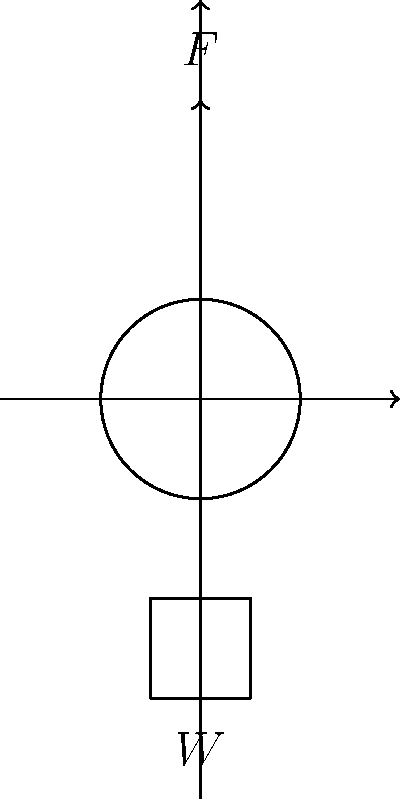E aí, cara! Tamo trabalhando num sistema de polia simples pra um equipamento de academia. Se a força $F$ aplicada pra levantar um peso $W$ é 200 N, qual é o peso da carga sendo levantada? Considera que não tem atrito e que a polia é ideal. Beleza, vamo nessa! Pra resolver isso, a gente precisa entender como funciona uma polia simples:

1) Numa polia simples ideal, a força aplicada $F$ é igual à tensão na corda.

2) Como a corda passa pela polia e sustenta o peso, a tensão na corda é igual ao peso $W$ que tá sendo levantado.

3) Então, numa polia simples ideal, a força aplicada $F$ é igual ao peso $W$ que tá sendo levantado.

4) Matematicamente, a gente pode escrever isso como:

   $$F = W$$

5) A gente sabe que a força aplicada $F$ é 200 N, então:

   $$200 \text{ N} = W$$

6) Portanto, o peso $W$ sendo levantado também é 200 N.

É isso aí, parceiro! Simples assim numa polia ideal.
Answer: 200 N 